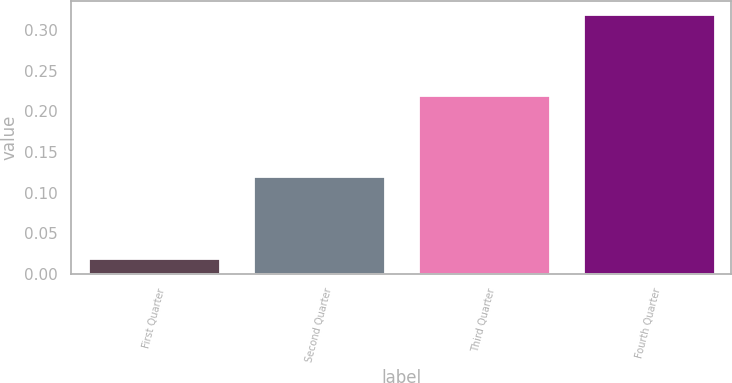Convert chart to OTSL. <chart><loc_0><loc_0><loc_500><loc_500><bar_chart><fcel>First Quarter<fcel>Second Quarter<fcel>Third Quarter<fcel>Fourth Quarter<nl><fcel>0.02<fcel>0.12<fcel>0.22<fcel>0.32<nl></chart> 